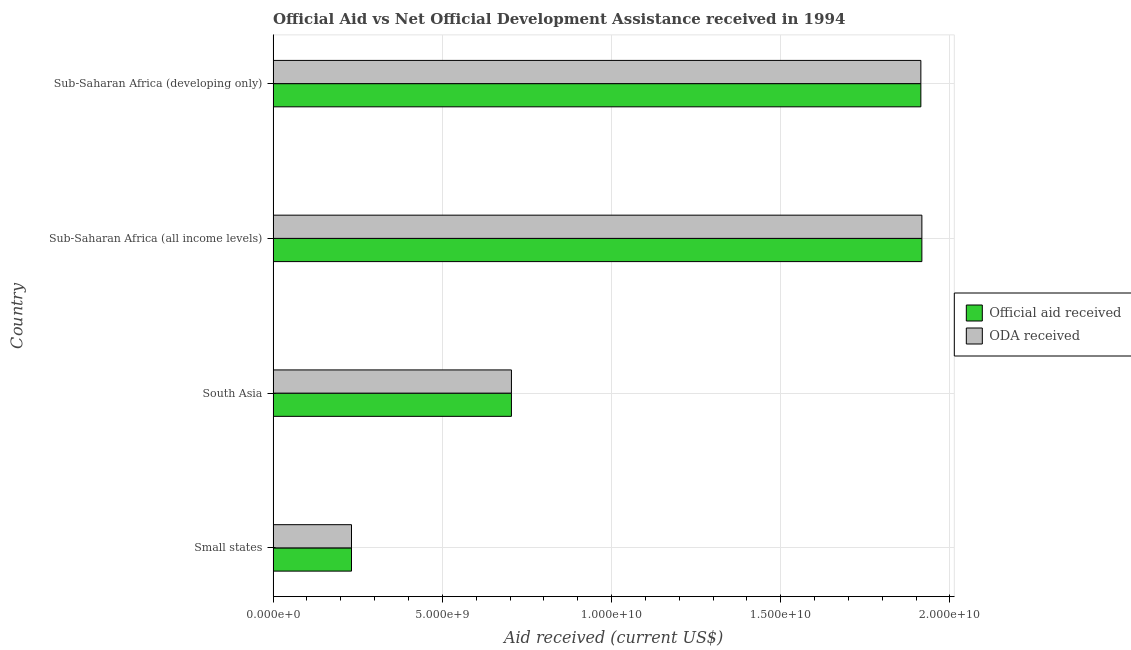Are the number of bars per tick equal to the number of legend labels?
Give a very brief answer. Yes. Are the number of bars on each tick of the Y-axis equal?
Provide a succinct answer. Yes. How many bars are there on the 1st tick from the top?
Provide a succinct answer. 2. What is the label of the 4th group of bars from the top?
Provide a succinct answer. Small states. What is the oda received in Sub-Saharan Africa (all income levels)?
Give a very brief answer. 1.92e+1. Across all countries, what is the maximum official aid received?
Keep it short and to the point. 1.92e+1. Across all countries, what is the minimum official aid received?
Your answer should be compact. 2.32e+09. In which country was the oda received maximum?
Ensure brevity in your answer.  Sub-Saharan Africa (all income levels). In which country was the official aid received minimum?
Make the answer very short. Small states. What is the total official aid received in the graph?
Provide a succinct answer. 4.77e+1. What is the difference between the oda received in South Asia and that in Sub-Saharan Africa (developing only)?
Make the answer very short. -1.21e+1. What is the difference between the official aid received in South Asia and the oda received in Sub-Saharan Africa (all income levels)?
Offer a terse response. -1.21e+1. What is the average official aid received per country?
Make the answer very short. 1.19e+1. What is the difference between the oda received and official aid received in South Asia?
Offer a terse response. 0. In how many countries, is the official aid received greater than 8000000000 US$?
Provide a short and direct response. 2. What is the ratio of the official aid received in South Asia to that in Sub-Saharan Africa (developing only)?
Keep it short and to the point. 0.37. Is the difference between the official aid received in South Asia and Sub-Saharan Africa (developing only) greater than the difference between the oda received in South Asia and Sub-Saharan Africa (developing only)?
Your response must be concise. No. What is the difference between the highest and the second highest official aid received?
Offer a very short reply. 2.97e+07. What is the difference between the highest and the lowest oda received?
Offer a terse response. 1.69e+1. Is the sum of the official aid received in South Asia and Sub-Saharan Africa (all income levels) greater than the maximum oda received across all countries?
Offer a very short reply. Yes. What does the 1st bar from the top in Sub-Saharan Africa (developing only) represents?
Provide a succinct answer. ODA received. What does the 2nd bar from the bottom in Sub-Saharan Africa (developing only) represents?
Your response must be concise. ODA received. Are all the bars in the graph horizontal?
Give a very brief answer. Yes. How many countries are there in the graph?
Your response must be concise. 4. What is the difference between two consecutive major ticks on the X-axis?
Your answer should be very brief. 5.00e+09. Are the values on the major ticks of X-axis written in scientific E-notation?
Provide a succinct answer. Yes. What is the title of the graph?
Your answer should be compact. Official Aid vs Net Official Development Assistance received in 1994 . What is the label or title of the X-axis?
Provide a short and direct response. Aid received (current US$). What is the label or title of the Y-axis?
Ensure brevity in your answer.  Country. What is the Aid received (current US$) of Official aid received in Small states?
Give a very brief answer. 2.32e+09. What is the Aid received (current US$) of ODA received in Small states?
Keep it short and to the point. 2.32e+09. What is the Aid received (current US$) in Official aid received in South Asia?
Give a very brief answer. 7.04e+09. What is the Aid received (current US$) in ODA received in South Asia?
Your response must be concise. 7.04e+09. What is the Aid received (current US$) of Official aid received in Sub-Saharan Africa (all income levels)?
Your response must be concise. 1.92e+1. What is the Aid received (current US$) of ODA received in Sub-Saharan Africa (all income levels)?
Keep it short and to the point. 1.92e+1. What is the Aid received (current US$) in Official aid received in Sub-Saharan Africa (developing only)?
Provide a succinct answer. 1.91e+1. What is the Aid received (current US$) of ODA received in Sub-Saharan Africa (developing only)?
Your answer should be compact. 1.91e+1. Across all countries, what is the maximum Aid received (current US$) in Official aid received?
Your answer should be very brief. 1.92e+1. Across all countries, what is the maximum Aid received (current US$) in ODA received?
Ensure brevity in your answer.  1.92e+1. Across all countries, what is the minimum Aid received (current US$) of Official aid received?
Offer a terse response. 2.32e+09. Across all countries, what is the minimum Aid received (current US$) in ODA received?
Your answer should be compact. 2.32e+09. What is the total Aid received (current US$) in Official aid received in the graph?
Keep it short and to the point. 4.77e+1. What is the total Aid received (current US$) of ODA received in the graph?
Offer a terse response. 4.77e+1. What is the difference between the Aid received (current US$) in Official aid received in Small states and that in South Asia?
Give a very brief answer. -4.73e+09. What is the difference between the Aid received (current US$) of ODA received in Small states and that in South Asia?
Provide a succinct answer. -4.73e+09. What is the difference between the Aid received (current US$) of Official aid received in Small states and that in Sub-Saharan Africa (all income levels)?
Provide a short and direct response. -1.69e+1. What is the difference between the Aid received (current US$) in ODA received in Small states and that in Sub-Saharan Africa (all income levels)?
Provide a succinct answer. -1.69e+1. What is the difference between the Aid received (current US$) in Official aid received in Small states and that in Sub-Saharan Africa (developing only)?
Ensure brevity in your answer.  -1.68e+1. What is the difference between the Aid received (current US$) in ODA received in Small states and that in Sub-Saharan Africa (developing only)?
Your answer should be compact. -1.68e+1. What is the difference between the Aid received (current US$) of Official aid received in South Asia and that in Sub-Saharan Africa (all income levels)?
Offer a very short reply. -1.21e+1. What is the difference between the Aid received (current US$) of ODA received in South Asia and that in Sub-Saharan Africa (all income levels)?
Make the answer very short. -1.21e+1. What is the difference between the Aid received (current US$) of Official aid received in South Asia and that in Sub-Saharan Africa (developing only)?
Provide a succinct answer. -1.21e+1. What is the difference between the Aid received (current US$) in ODA received in South Asia and that in Sub-Saharan Africa (developing only)?
Give a very brief answer. -1.21e+1. What is the difference between the Aid received (current US$) in Official aid received in Sub-Saharan Africa (all income levels) and that in Sub-Saharan Africa (developing only)?
Provide a short and direct response. 2.97e+07. What is the difference between the Aid received (current US$) in ODA received in Sub-Saharan Africa (all income levels) and that in Sub-Saharan Africa (developing only)?
Offer a very short reply. 2.97e+07. What is the difference between the Aid received (current US$) in Official aid received in Small states and the Aid received (current US$) in ODA received in South Asia?
Your response must be concise. -4.73e+09. What is the difference between the Aid received (current US$) in Official aid received in Small states and the Aid received (current US$) in ODA received in Sub-Saharan Africa (all income levels)?
Your response must be concise. -1.69e+1. What is the difference between the Aid received (current US$) in Official aid received in Small states and the Aid received (current US$) in ODA received in Sub-Saharan Africa (developing only)?
Keep it short and to the point. -1.68e+1. What is the difference between the Aid received (current US$) in Official aid received in South Asia and the Aid received (current US$) in ODA received in Sub-Saharan Africa (all income levels)?
Provide a succinct answer. -1.21e+1. What is the difference between the Aid received (current US$) of Official aid received in South Asia and the Aid received (current US$) of ODA received in Sub-Saharan Africa (developing only)?
Offer a very short reply. -1.21e+1. What is the difference between the Aid received (current US$) in Official aid received in Sub-Saharan Africa (all income levels) and the Aid received (current US$) in ODA received in Sub-Saharan Africa (developing only)?
Provide a short and direct response. 2.97e+07. What is the average Aid received (current US$) of Official aid received per country?
Give a very brief answer. 1.19e+1. What is the average Aid received (current US$) in ODA received per country?
Provide a short and direct response. 1.19e+1. What is the difference between the Aid received (current US$) of Official aid received and Aid received (current US$) of ODA received in South Asia?
Your response must be concise. 0. What is the difference between the Aid received (current US$) of Official aid received and Aid received (current US$) of ODA received in Sub-Saharan Africa (all income levels)?
Make the answer very short. 0. What is the difference between the Aid received (current US$) in Official aid received and Aid received (current US$) in ODA received in Sub-Saharan Africa (developing only)?
Ensure brevity in your answer.  0. What is the ratio of the Aid received (current US$) of Official aid received in Small states to that in South Asia?
Keep it short and to the point. 0.33. What is the ratio of the Aid received (current US$) of ODA received in Small states to that in South Asia?
Provide a succinct answer. 0.33. What is the ratio of the Aid received (current US$) of Official aid received in Small states to that in Sub-Saharan Africa (all income levels)?
Make the answer very short. 0.12. What is the ratio of the Aid received (current US$) in ODA received in Small states to that in Sub-Saharan Africa (all income levels)?
Your response must be concise. 0.12. What is the ratio of the Aid received (current US$) in Official aid received in Small states to that in Sub-Saharan Africa (developing only)?
Offer a very short reply. 0.12. What is the ratio of the Aid received (current US$) in ODA received in Small states to that in Sub-Saharan Africa (developing only)?
Give a very brief answer. 0.12. What is the ratio of the Aid received (current US$) in Official aid received in South Asia to that in Sub-Saharan Africa (all income levels)?
Your answer should be compact. 0.37. What is the ratio of the Aid received (current US$) of ODA received in South Asia to that in Sub-Saharan Africa (all income levels)?
Give a very brief answer. 0.37. What is the ratio of the Aid received (current US$) in Official aid received in South Asia to that in Sub-Saharan Africa (developing only)?
Ensure brevity in your answer.  0.37. What is the ratio of the Aid received (current US$) of ODA received in South Asia to that in Sub-Saharan Africa (developing only)?
Offer a terse response. 0.37. What is the ratio of the Aid received (current US$) in Official aid received in Sub-Saharan Africa (all income levels) to that in Sub-Saharan Africa (developing only)?
Ensure brevity in your answer.  1. What is the ratio of the Aid received (current US$) in ODA received in Sub-Saharan Africa (all income levels) to that in Sub-Saharan Africa (developing only)?
Give a very brief answer. 1. What is the difference between the highest and the second highest Aid received (current US$) in Official aid received?
Ensure brevity in your answer.  2.97e+07. What is the difference between the highest and the second highest Aid received (current US$) in ODA received?
Ensure brevity in your answer.  2.97e+07. What is the difference between the highest and the lowest Aid received (current US$) in Official aid received?
Make the answer very short. 1.69e+1. What is the difference between the highest and the lowest Aid received (current US$) of ODA received?
Keep it short and to the point. 1.69e+1. 